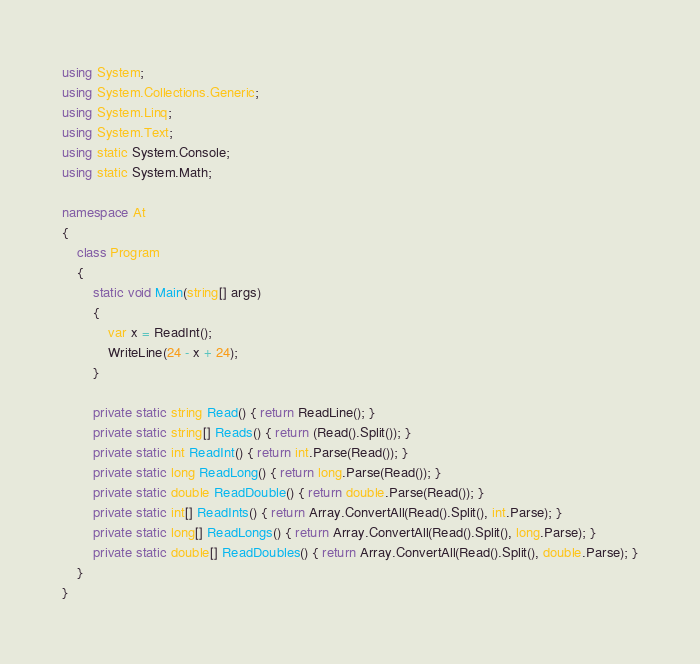<code> <loc_0><loc_0><loc_500><loc_500><_C#_>using System;
using System.Collections.Generic;
using System.Linq;
using System.Text;
using static System.Console;
using static System.Math;

namespace At
{
    class Program
    {
        static void Main(string[] args)
        {
            var x = ReadInt();
            WriteLine(24 - x + 24);
        }

        private static string Read() { return ReadLine(); }
        private static string[] Reads() { return (Read().Split()); }
        private static int ReadInt() { return int.Parse(Read()); }
        private static long ReadLong() { return long.Parse(Read()); }
        private static double ReadDouble() { return double.Parse(Read()); }
        private static int[] ReadInts() { return Array.ConvertAll(Read().Split(), int.Parse); }
        private static long[] ReadLongs() { return Array.ConvertAll(Read().Split(), long.Parse); }
        private static double[] ReadDoubles() { return Array.ConvertAll(Read().Split(), double.Parse); }
    }
}
</code> 